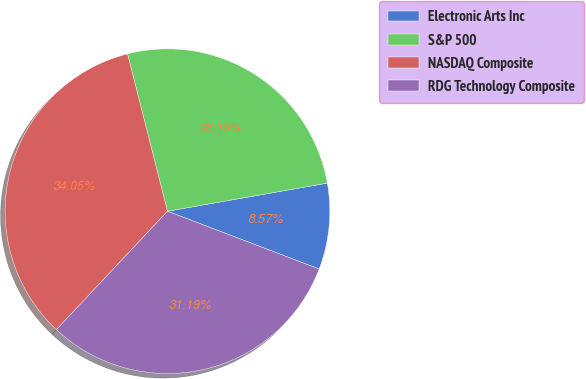Convert chart. <chart><loc_0><loc_0><loc_500><loc_500><pie_chart><fcel>Electronic Arts Inc<fcel>S&P 500<fcel>NASDAQ Composite<fcel>RDG Technology Composite<nl><fcel>8.57%<fcel>26.19%<fcel>34.05%<fcel>31.19%<nl></chart> 